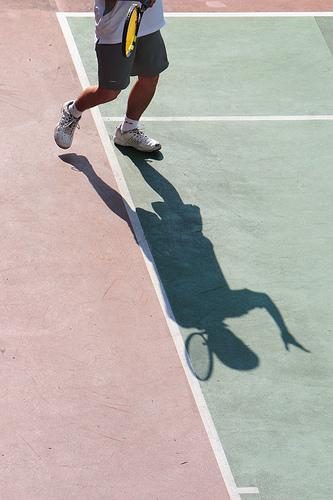Question: who is it?
Choices:
A. The mechanic.
B. Mom.
C. Dad.
D. The guy.
Answer with the letter. Answer: D Question: where is the racket?
Choices:
A. On the porch.
B. In the locker.
C. On the table.
D. In the hand.
Answer with the letter. Answer: D Question: what will he hit?
Choices:
A. Ball.
B. Baseball.
C. Basketball.
D. Tennis ball.
Answer with the letter. Answer: A 